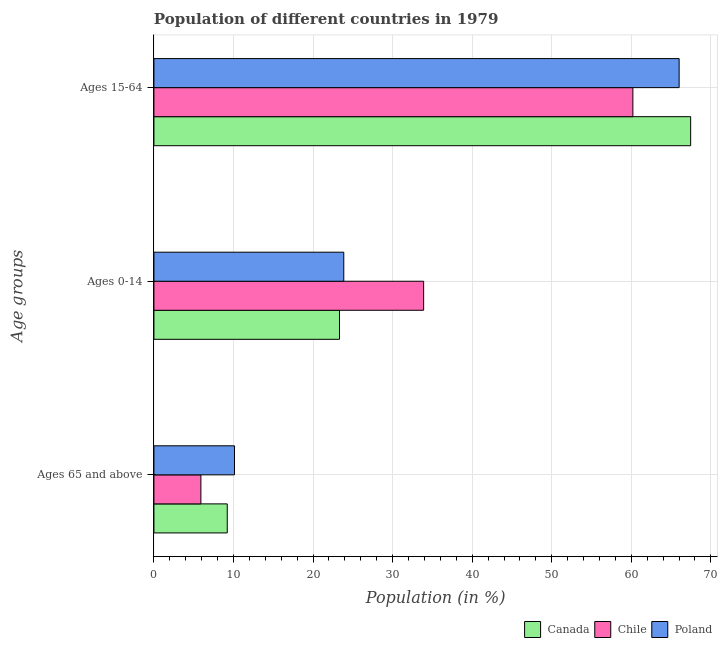How many different coloured bars are there?
Ensure brevity in your answer.  3. How many groups of bars are there?
Your response must be concise. 3. What is the label of the 2nd group of bars from the top?
Your response must be concise. Ages 0-14. What is the percentage of population within the age-group 15-64 in Poland?
Offer a terse response. 66.01. Across all countries, what is the maximum percentage of population within the age-group of 65 and above?
Give a very brief answer. 10.13. Across all countries, what is the minimum percentage of population within the age-group 0-14?
Keep it short and to the point. 23.32. In which country was the percentage of population within the age-group 15-64 maximum?
Ensure brevity in your answer.  Canada. What is the total percentage of population within the age-group 15-64 in the graph?
Ensure brevity in your answer.  193.67. What is the difference between the percentage of population within the age-group 15-64 in Canada and that in Chile?
Offer a terse response. 7.26. What is the difference between the percentage of population within the age-group 15-64 in Canada and the percentage of population within the age-group 0-14 in Chile?
Provide a succinct answer. 33.56. What is the average percentage of population within the age-group 0-14 per country?
Offer a very short reply. 27.03. What is the difference between the percentage of population within the age-group 0-14 and percentage of population within the age-group of 65 and above in Poland?
Your answer should be very brief. 13.74. What is the ratio of the percentage of population within the age-group 15-64 in Chile to that in Poland?
Your answer should be very brief. 0.91. Is the difference between the percentage of population within the age-group 0-14 in Canada and Poland greater than the difference between the percentage of population within the age-group of 65 and above in Canada and Poland?
Offer a very short reply. Yes. What is the difference between the highest and the second highest percentage of population within the age-group of 65 and above?
Your answer should be compact. 0.91. What is the difference between the highest and the lowest percentage of population within the age-group 15-64?
Offer a very short reply. 7.26. Is the sum of the percentage of population within the age-group 0-14 in Chile and Canada greater than the maximum percentage of population within the age-group 15-64 across all countries?
Offer a very short reply. No. Is it the case that in every country, the sum of the percentage of population within the age-group of 65 and above and percentage of population within the age-group 0-14 is greater than the percentage of population within the age-group 15-64?
Keep it short and to the point. No. How many bars are there?
Give a very brief answer. 9. Does the graph contain grids?
Make the answer very short. Yes. Where does the legend appear in the graph?
Give a very brief answer. Bottom right. How many legend labels are there?
Your answer should be compact. 3. What is the title of the graph?
Your response must be concise. Population of different countries in 1979. Does "Central Europe" appear as one of the legend labels in the graph?
Ensure brevity in your answer.  No. What is the label or title of the Y-axis?
Your answer should be compact. Age groups. What is the Population (in %) in Canada in Ages 65 and above?
Your response must be concise. 9.22. What is the Population (in %) of Chile in Ages 65 and above?
Your answer should be very brief. 5.9. What is the Population (in %) in Poland in Ages 65 and above?
Your response must be concise. 10.13. What is the Population (in %) in Canada in Ages 0-14?
Make the answer very short. 23.32. What is the Population (in %) of Chile in Ages 0-14?
Your answer should be very brief. 33.9. What is the Population (in %) of Poland in Ages 0-14?
Give a very brief answer. 23.86. What is the Population (in %) in Canada in Ages 15-64?
Offer a very short reply. 67.46. What is the Population (in %) of Chile in Ages 15-64?
Offer a terse response. 60.2. What is the Population (in %) in Poland in Ages 15-64?
Provide a short and direct response. 66.01. Across all Age groups, what is the maximum Population (in %) in Canada?
Make the answer very short. 67.46. Across all Age groups, what is the maximum Population (in %) of Chile?
Ensure brevity in your answer.  60.2. Across all Age groups, what is the maximum Population (in %) of Poland?
Ensure brevity in your answer.  66.01. Across all Age groups, what is the minimum Population (in %) in Canada?
Give a very brief answer. 9.22. Across all Age groups, what is the minimum Population (in %) in Chile?
Offer a very short reply. 5.9. Across all Age groups, what is the minimum Population (in %) in Poland?
Offer a very short reply. 10.13. What is the total Population (in %) of Canada in the graph?
Provide a succinct answer. 100. What is the total Population (in %) in Chile in the graph?
Ensure brevity in your answer.  100. What is the total Population (in %) in Poland in the graph?
Your answer should be very brief. 100. What is the difference between the Population (in %) of Canada in Ages 65 and above and that in Ages 0-14?
Keep it short and to the point. -14.11. What is the difference between the Population (in %) in Chile in Ages 65 and above and that in Ages 0-14?
Ensure brevity in your answer.  -28. What is the difference between the Population (in %) in Poland in Ages 65 and above and that in Ages 0-14?
Give a very brief answer. -13.74. What is the difference between the Population (in %) in Canada in Ages 65 and above and that in Ages 15-64?
Provide a succinct answer. -58.24. What is the difference between the Population (in %) in Chile in Ages 65 and above and that in Ages 15-64?
Offer a very short reply. -54.29. What is the difference between the Population (in %) of Poland in Ages 65 and above and that in Ages 15-64?
Provide a succinct answer. -55.89. What is the difference between the Population (in %) of Canada in Ages 0-14 and that in Ages 15-64?
Your answer should be very brief. -44.14. What is the difference between the Population (in %) in Chile in Ages 0-14 and that in Ages 15-64?
Your answer should be very brief. -26.3. What is the difference between the Population (in %) in Poland in Ages 0-14 and that in Ages 15-64?
Ensure brevity in your answer.  -42.15. What is the difference between the Population (in %) of Canada in Ages 65 and above and the Population (in %) of Chile in Ages 0-14?
Your answer should be very brief. -24.68. What is the difference between the Population (in %) in Canada in Ages 65 and above and the Population (in %) in Poland in Ages 0-14?
Keep it short and to the point. -14.65. What is the difference between the Population (in %) in Chile in Ages 65 and above and the Population (in %) in Poland in Ages 0-14?
Make the answer very short. -17.96. What is the difference between the Population (in %) of Canada in Ages 65 and above and the Population (in %) of Chile in Ages 15-64?
Your answer should be very brief. -50.98. What is the difference between the Population (in %) in Canada in Ages 65 and above and the Population (in %) in Poland in Ages 15-64?
Provide a short and direct response. -56.8. What is the difference between the Population (in %) in Chile in Ages 65 and above and the Population (in %) in Poland in Ages 15-64?
Give a very brief answer. -60.11. What is the difference between the Population (in %) in Canada in Ages 0-14 and the Population (in %) in Chile in Ages 15-64?
Your answer should be compact. -36.87. What is the difference between the Population (in %) in Canada in Ages 0-14 and the Population (in %) in Poland in Ages 15-64?
Make the answer very short. -42.69. What is the difference between the Population (in %) in Chile in Ages 0-14 and the Population (in %) in Poland in Ages 15-64?
Provide a succinct answer. -32.11. What is the average Population (in %) of Canada per Age groups?
Your answer should be compact. 33.33. What is the average Population (in %) in Chile per Age groups?
Provide a short and direct response. 33.33. What is the average Population (in %) in Poland per Age groups?
Keep it short and to the point. 33.33. What is the difference between the Population (in %) of Canada and Population (in %) of Chile in Ages 65 and above?
Provide a short and direct response. 3.31. What is the difference between the Population (in %) of Canada and Population (in %) of Poland in Ages 65 and above?
Your answer should be compact. -0.91. What is the difference between the Population (in %) of Chile and Population (in %) of Poland in Ages 65 and above?
Make the answer very short. -4.22. What is the difference between the Population (in %) of Canada and Population (in %) of Chile in Ages 0-14?
Offer a very short reply. -10.58. What is the difference between the Population (in %) in Canada and Population (in %) in Poland in Ages 0-14?
Give a very brief answer. -0.54. What is the difference between the Population (in %) in Chile and Population (in %) in Poland in Ages 0-14?
Make the answer very short. 10.04. What is the difference between the Population (in %) in Canada and Population (in %) in Chile in Ages 15-64?
Your answer should be very brief. 7.26. What is the difference between the Population (in %) of Canada and Population (in %) of Poland in Ages 15-64?
Keep it short and to the point. 1.45. What is the difference between the Population (in %) in Chile and Population (in %) in Poland in Ages 15-64?
Make the answer very short. -5.82. What is the ratio of the Population (in %) in Canada in Ages 65 and above to that in Ages 0-14?
Offer a terse response. 0.4. What is the ratio of the Population (in %) in Chile in Ages 65 and above to that in Ages 0-14?
Keep it short and to the point. 0.17. What is the ratio of the Population (in %) of Poland in Ages 65 and above to that in Ages 0-14?
Provide a succinct answer. 0.42. What is the ratio of the Population (in %) in Canada in Ages 65 and above to that in Ages 15-64?
Provide a short and direct response. 0.14. What is the ratio of the Population (in %) in Chile in Ages 65 and above to that in Ages 15-64?
Ensure brevity in your answer.  0.1. What is the ratio of the Population (in %) of Poland in Ages 65 and above to that in Ages 15-64?
Keep it short and to the point. 0.15. What is the ratio of the Population (in %) of Canada in Ages 0-14 to that in Ages 15-64?
Offer a very short reply. 0.35. What is the ratio of the Population (in %) in Chile in Ages 0-14 to that in Ages 15-64?
Your answer should be compact. 0.56. What is the ratio of the Population (in %) in Poland in Ages 0-14 to that in Ages 15-64?
Your answer should be compact. 0.36. What is the difference between the highest and the second highest Population (in %) in Canada?
Give a very brief answer. 44.14. What is the difference between the highest and the second highest Population (in %) in Chile?
Your response must be concise. 26.3. What is the difference between the highest and the second highest Population (in %) in Poland?
Provide a short and direct response. 42.15. What is the difference between the highest and the lowest Population (in %) in Canada?
Your answer should be compact. 58.24. What is the difference between the highest and the lowest Population (in %) in Chile?
Make the answer very short. 54.29. What is the difference between the highest and the lowest Population (in %) of Poland?
Your answer should be very brief. 55.89. 